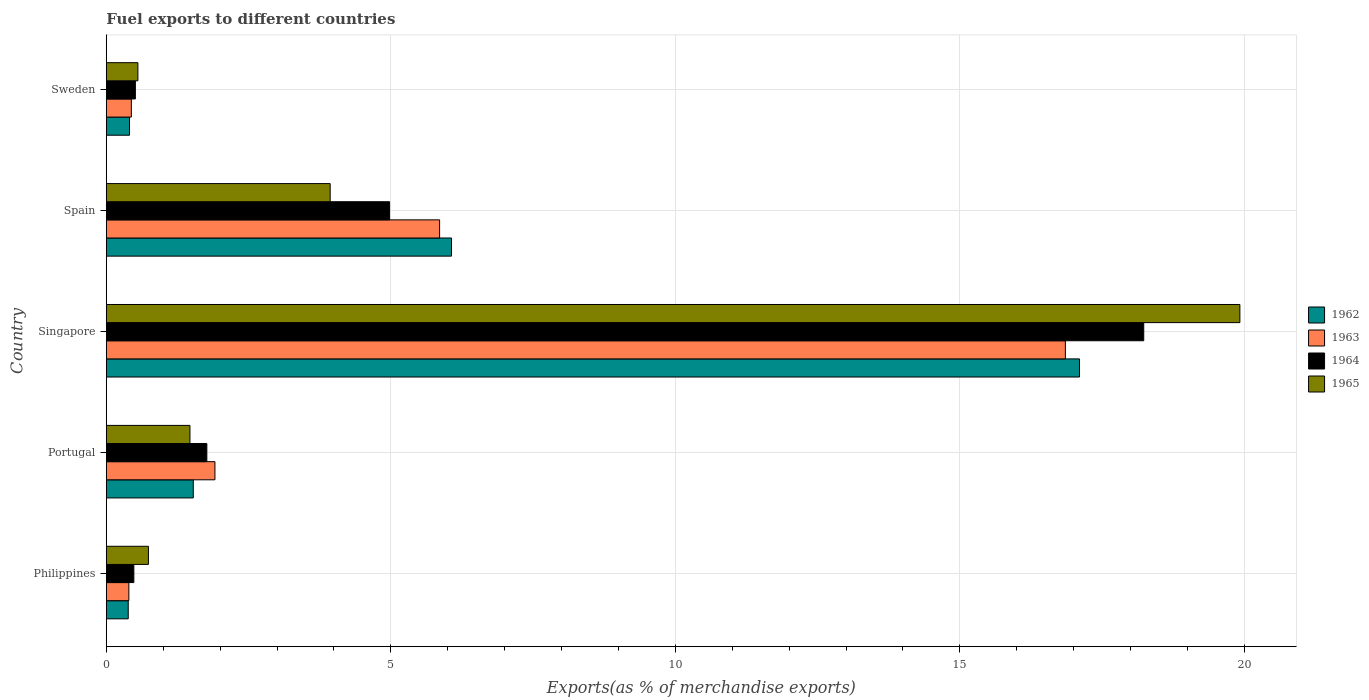Are the number of bars per tick equal to the number of legend labels?
Your answer should be compact. Yes. How many bars are there on the 3rd tick from the top?
Make the answer very short. 4. How many bars are there on the 5th tick from the bottom?
Offer a very short reply. 4. What is the label of the 5th group of bars from the top?
Your answer should be compact. Philippines. What is the percentage of exports to different countries in 1962 in Portugal?
Your answer should be very brief. 1.53. Across all countries, what is the maximum percentage of exports to different countries in 1965?
Provide a succinct answer. 19.92. Across all countries, what is the minimum percentage of exports to different countries in 1963?
Give a very brief answer. 0.4. In which country was the percentage of exports to different countries in 1965 maximum?
Make the answer very short. Singapore. What is the total percentage of exports to different countries in 1964 in the graph?
Offer a terse response. 25.97. What is the difference between the percentage of exports to different countries in 1964 in Spain and that in Sweden?
Provide a short and direct response. 4.47. What is the difference between the percentage of exports to different countries in 1964 in Portugal and the percentage of exports to different countries in 1965 in Philippines?
Offer a terse response. 1.03. What is the average percentage of exports to different countries in 1962 per country?
Provide a succinct answer. 5.1. What is the difference between the percentage of exports to different countries in 1964 and percentage of exports to different countries in 1965 in Sweden?
Your response must be concise. -0.04. What is the ratio of the percentage of exports to different countries in 1964 in Portugal to that in Spain?
Make the answer very short. 0.35. Is the percentage of exports to different countries in 1962 in Philippines less than that in Portugal?
Your answer should be compact. Yes. What is the difference between the highest and the second highest percentage of exports to different countries in 1963?
Offer a very short reply. 11. What is the difference between the highest and the lowest percentage of exports to different countries in 1964?
Your answer should be compact. 17.75. Is the sum of the percentage of exports to different countries in 1963 in Philippines and Spain greater than the maximum percentage of exports to different countries in 1962 across all countries?
Offer a very short reply. No. What does the 2nd bar from the top in Philippines represents?
Your answer should be compact. 1964. Is it the case that in every country, the sum of the percentage of exports to different countries in 1964 and percentage of exports to different countries in 1963 is greater than the percentage of exports to different countries in 1962?
Offer a terse response. Yes. How many bars are there?
Your answer should be compact. 20. Are all the bars in the graph horizontal?
Provide a short and direct response. Yes. How many countries are there in the graph?
Ensure brevity in your answer.  5. What is the difference between two consecutive major ticks on the X-axis?
Give a very brief answer. 5. Where does the legend appear in the graph?
Offer a very short reply. Center right. How many legend labels are there?
Offer a terse response. 4. How are the legend labels stacked?
Offer a very short reply. Vertical. What is the title of the graph?
Your answer should be compact. Fuel exports to different countries. What is the label or title of the X-axis?
Your answer should be compact. Exports(as % of merchandise exports). What is the Exports(as % of merchandise exports) in 1962 in Philippines?
Provide a succinct answer. 0.38. What is the Exports(as % of merchandise exports) of 1963 in Philippines?
Offer a very short reply. 0.4. What is the Exports(as % of merchandise exports) in 1964 in Philippines?
Give a very brief answer. 0.48. What is the Exports(as % of merchandise exports) of 1965 in Philippines?
Provide a short and direct response. 0.74. What is the Exports(as % of merchandise exports) in 1962 in Portugal?
Make the answer very short. 1.53. What is the Exports(as % of merchandise exports) of 1963 in Portugal?
Offer a very short reply. 1.91. What is the Exports(as % of merchandise exports) of 1964 in Portugal?
Your response must be concise. 1.77. What is the Exports(as % of merchandise exports) in 1965 in Portugal?
Provide a short and direct response. 1.47. What is the Exports(as % of merchandise exports) of 1962 in Singapore?
Keep it short and to the point. 17.1. What is the Exports(as % of merchandise exports) of 1963 in Singapore?
Your response must be concise. 16.85. What is the Exports(as % of merchandise exports) in 1964 in Singapore?
Make the answer very short. 18.23. What is the Exports(as % of merchandise exports) of 1965 in Singapore?
Provide a short and direct response. 19.92. What is the Exports(as % of merchandise exports) of 1962 in Spain?
Ensure brevity in your answer.  6.07. What is the Exports(as % of merchandise exports) of 1963 in Spain?
Make the answer very short. 5.86. What is the Exports(as % of merchandise exports) of 1964 in Spain?
Keep it short and to the point. 4.98. What is the Exports(as % of merchandise exports) in 1965 in Spain?
Ensure brevity in your answer.  3.93. What is the Exports(as % of merchandise exports) of 1962 in Sweden?
Provide a succinct answer. 0.41. What is the Exports(as % of merchandise exports) of 1963 in Sweden?
Provide a short and direct response. 0.44. What is the Exports(as % of merchandise exports) in 1964 in Sweden?
Ensure brevity in your answer.  0.51. What is the Exports(as % of merchandise exports) of 1965 in Sweden?
Offer a very short reply. 0.55. Across all countries, what is the maximum Exports(as % of merchandise exports) in 1962?
Offer a terse response. 17.1. Across all countries, what is the maximum Exports(as % of merchandise exports) in 1963?
Give a very brief answer. 16.85. Across all countries, what is the maximum Exports(as % of merchandise exports) of 1964?
Offer a very short reply. 18.23. Across all countries, what is the maximum Exports(as % of merchandise exports) in 1965?
Ensure brevity in your answer.  19.92. Across all countries, what is the minimum Exports(as % of merchandise exports) of 1962?
Provide a succinct answer. 0.38. Across all countries, what is the minimum Exports(as % of merchandise exports) of 1963?
Offer a very short reply. 0.4. Across all countries, what is the minimum Exports(as % of merchandise exports) in 1964?
Ensure brevity in your answer.  0.48. Across all countries, what is the minimum Exports(as % of merchandise exports) in 1965?
Keep it short and to the point. 0.55. What is the total Exports(as % of merchandise exports) of 1962 in the graph?
Provide a succinct answer. 25.49. What is the total Exports(as % of merchandise exports) of 1963 in the graph?
Offer a very short reply. 25.46. What is the total Exports(as % of merchandise exports) of 1964 in the graph?
Your response must be concise. 25.97. What is the total Exports(as % of merchandise exports) in 1965 in the graph?
Provide a short and direct response. 26.62. What is the difference between the Exports(as % of merchandise exports) in 1962 in Philippines and that in Portugal?
Your answer should be very brief. -1.14. What is the difference between the Exports(as % of merchandise exports) in 1963 in Philippines and that in Portugal?
Offer a very short reply. -1.51. What is the difference between the Exports(as % of merchandise exports) in 1964 in Philippines and that in Portugal?
Provide a short and direct response. -1.28. What is the difference between the Exports(as % of merchandise exports) in 1965 in Philippines and that in Portugal?
Offer a terse response. -0.73. What is the difference between the Exports(as % of merchandise exports) in 1962 in Philippines and that in Singapore?
Your response must be concise. -16.72. What is the difference between the Exports(as % of merchandise exports) of 1963 in Philippines and that in Singapore?
Offer a terse response. -16.46. What is the difference between the Exports(as % of merchandise exports) in 1964 in Philippines and that in Singapore?
Offer a very short reply. -17.75. What is the difference between the Exports(as % of merchandise exports) in 1965 in Philippines and that in Singapore?
Provide a succinct answer. -19.18. What is the difference between the Exports(as % of merchandise exports) of 1962 in Philippines and that in Spain?
Provide a short and direct response. -5.68. What is the difference between the Exports(as % of merchandise exports) in 1963 in Philippines and that in Spain?
Make the answer very short. -5.46. What is the difference between the Exports(as % of merchandise exports) of 1964 in Philippines and that in Spain?
Give a very brief answer. -4.49. What is the difference between the Exports(as % of merchandise exports) of 1965 in Philippines and that in Spain?
Provide a succinct answer. -3.19. What is the difference between the Exports(as % of merchandise exports) in 1962 in Philippines and that in Sweden?
Make the answer very short. -0.02. What is the difference between the Exports(as % of merchandise exports) in 1963 in Philippines and that in Sweden?
Keep it short and to the point. -0.04. What is the difference between the Exports(as % of merchandise exports) in 1964 in Philippines and that in Sweden?
Ensure brevity in your answer.  -0.03. What is the difference between the Exports(as % of merchandise exports) of 1965 in Philippines and that in Sweden?
Keep it short and to the point. 0.19. What is the difference between the Exports(as % of merchandise exports) of 1962 in Portugal and that in Singapore?
Your answer should be compact. -15.58. What is the difference between the Exports(as % of merchandise exports) of 1963 in Portugal and that in Singapore?
Provide a short and direct response. -14.95. What is the difference between the Exports(as % of merchandise exports) in 1964 in Portugal and that in Singapore?
Ensure brevity in your answer.  -16.47. What is the difference between the Exports(as % of merchandise exports) in 1965 in Portugal and that in Singapore?
Provide a succinct answer. -18.45. What is the difference between the Exports(as % of merchandise exports) of 1962 in Portugal and that in Spain?
Offer a very short reply. -4.54. What is the difference between the Exports(as % of merchandise exports) in 1963 in Portugal and that in Spain?
Your answer should be very brief. -3.95. What is the difference between the Exports(as % of merchandise exports) in 1964 in Portugal and that in Spain?
Offer a very short reply. -3.21. What is the difference between the Exports(as % of merchandise exports) of 1965 in Portugal and that in Spain?
Provide a short and direct response. -2.46. What is the difference between the Exports(as % of merchandise exports) in 1962 in Portugal and that in Sweden?
Provide a succinct answer. 1.12. What is the difference between the Exports(as % of merchandise exports) of 1963 in Portugal and that in Sweden?
Provide a succinct answer. 1.47. What is the difference between the Exports(as % of merchandise exports) in 1964 in Portugal and that in Sweden?
Your answer should be compact. 1.26. What is the difference between the Exports(as % of merchandise exports) of 1965 in Portugal and that in Sweden?
Make the answer very short. 0.91. What is the difference between the Exports(as % of merchandise exports) of 1962 in Singapore and that in Spain?
Your answer should be very brief. 11.04. What is the difference between the Exports(as % of merchandise exports) of 1963 in Singapore and that in Spain?
Provide a succinct answer. 11. What is the difference between the Exports(as % of merchandise exports) of 1964 in Singapore and that in Spain?
Offer a terse response. 13.25. What is the difference between the Exports(as % of merchandise exports) in 1965 in Singapore and that in Spain?
Offer a very short reply. 15.99. What is the difference between the Exports(as % of merchandise exports) in 1962 in Singapore and that in Sweden?
Offer a terse response. 16.7. What is the difference between the Exports(as % of merchandise exports) of 1963 in Singapore and that in Sweden?
Your response must be concise. 16.42. What is the difference between the Exports(as % of merchandise exports) in 1964 in Singapore and that in Sweden?
Make the answer very short. 17.72. What is the difference between the Exports(as % of merchandise exports) in 1965 in Singapore and that in Sweden?
Give a very brief answer. 19.37. What is the difference between the Exports(as % of merchandise exports) in 1962 in Spain and that in Sweden?
Offer a terse response. 5.66. What is the difference between the Exports(as % of merchandise exports) in 1963 in Spain and that in Sweden?
Keep it short and to the point. 5.42. What is the difference between the Exports(as % of merchandise exports) in 1964 in Spain and that in Sweden?
Provide a short and direct response. 4.47. What is the difference between the Exports(as % of merchandise exports) of 1965 in Spain and that in Sweden?
Your response must be concise. 3.38. What is the difference between the Exports(as % of merchandise exports) of 1962 in Philippines and the Exports(as % of merchandise exports) of 1963 in Portugal?
Offer a very short reply. -1.52. What is the difference between the Exports(as % of merchandise exports) in 1962 in Philippines and the Exports(as % of merchandise exports) in 1964 in Portugal?
Make the answer very short. -1.38. What is the difference between the Exports(as % of merchandise exports) in 1962 in Philippines and the Exports(as % of merchandise exports) in 1965 in Portugal?
Give a very brief answer. -1.08. What is the difference between the Exports(as % of merchandise exports) in 1963 in Philippines and the Exports(as % of merchandise exports) in 1964 in Portugal?
Your answer should be very brief. -1.37. What is the difference between the Exports(as % of merchandise exports) in 1963 in Philippines and the Exports(as % of merchandise exports) in 1965 in Portugal?
Your response must be concise. -1.07. What is the difference between the Exports(as % of merchandise exports) of 1964 in Philippines and the Exports(as % of merchandise exports) of 1965 in Portugal?
Make the answer very short. -0.99. What is the difference between the Exports(as % of merchandise exports) in 1962 in Philippines and the Exports(as % of merchandise exports) in 1963 in Singapore?
Ensure brevity in your answer.  -16.47. What is the difference between the Exports(as % of merchandise exports) in 1962 in Philippines and the Exports(as % of merchandise exports) in 1964 in Singapore?
Offer a very short reply. -17.85. What is the difference between the Exports(as % of merchandise exports) in 1962 in Philippines and the Exports(as % of merchandise exports) in 1965 in Singapore?
Give a very brief answer. -19.54. What is the difference between the Exports(as % of merchandise exports) of 1963 in Philippines and the Exports(as % of merchandise exports) of 1964 in Singapore?
Make the answer very short. -17.84. What is the difference between the Exports(as % of merchandise exports) of 1963 in Philippines and the Exports(as % of merchandise exports) of 1965 in Singapore?
Keep it short and to the point. -19.53. What is the difference between the Exports(as % of merchandise exports) in 1964 in Philippines and the Exports(as % of merchandise exports) in 1965 in Singapore?
Give a very brief answer. -19.44. What is the difference between the Exports(as % of merchandise exports) in 1962 in Philippines and the Exports(as % of merchandise exports) in 1963 in Spain?
Your answer should be compact. -5.47. What is the difference between the Exports(as % of merchandise exports) of 1962 in Philippines and the Exports(as % of merchandise exports) of 1964 in Spain?
Your answer should be compact. -4.59. What is the difference between the Exports(as % of merchandise exports) in 1962 in Philippines and the Exports(as % of merchandise exports) in 1965 in Spain?
Offer a very short reply. -3.55. What is the difference between the Exports(as % of merchandise exports) of 1963 in Philippines and the Exports(as % of merchandise exports) of 1964 in Spain?
Keep it short and to the point. -4.58. What is the difference between the Exports(as % of merchandise exports) in 1963 in Philippines and the Exports(as % of merchandise exports) in 1965 in Spain?
Your response must be concise. -3.54. What is the difference between the Exports(as % of merchandise exports) in 1964 in Philippines and the Exports(as % of merchandise exports) in 1965 in Spain?
Offer a terse response. -3.45. What is the difference between the Exports(as % of merchandise exports) in 1962 in Philippines and the Exports(as % of merchandise exports) in 1963 in Sweden?
Give a very brief answer. -0.05. What is the difference between the Exports(as % of merchandise exports) in 1962 in Philippines and the Exports(as % of merchandise exports) in 1964 in Sweden?
Offer a terse response. -0.13. What is the difference between the Exports(as % of merchandise exports) in 1962 in Philippines and the Exports(as % of merchandise exports) in 1965 in Sweden?
Your answer should be very brief. -0.17. What is the difference between the Exports(as % of merchandise exports) of 1963 in Philippines and the Exports(as % of merchandise exports) of 1964 in Sweden?
Ensure brevity in your answer.  -0.11. What is the difference between the Exports(as % of merchandise exports) in 1963 in Philippines and the Exports(as % of merchandise exports) in 1965 in Sweden?
Offer a very short reply. -0.16. What is the difference between the Exports(as % of merchandise exports) in 1964 in Philippines and the Exports(as % of merchandise exports) in 1965 in Sweden?
Offer a very short reply. -0.07. What is the difference between the Exports(as % of merchandise exports) of 1962 in Portugal and the Exports(as % of merchandise exports) of 1963 in Singapore?
Offer a very short reply. -15.33. What is the difference between the Exports(as % of merchandise exports) of 1962 in Portugal and the Exports(as % of merchandise exports) of 1964 in Singapore?
Keep it short and to the point. -16.7. What is the difference between the Exports(as % of merchandise exports) in 1962 in Portugal and the Exports(as % of merchandise exports) in 1965 in Singapore?
Offer a terse response. -18.39. What is the difference between the Exports(as % of merchandise exports) of 1963 in Portugal and the Exports(as % of merchandise exports) of 1964 in Singapore?
Ensure brevity in your answer.  -16.32. What is the difference between the Exports(as % of merchandise exports) in 1963 in Portugal and the Exports(as % of merchandise exports) in 1965 in Singapore?
Give a very brief answer. -18.01. What is the difference between the Exports(as % of merchandise exports) in 1964 in Portugal and the Exports(as % of merchandise exports) in 1965 in Singapore?
Your answer should be compact. -18.16. What is the difference between the Exports(as % of merchandise exports) in 1962 in Portugal and the Exports(as % of merchandise exports) in 1963 in Spain?
Keep it short and to the point. -4.33. What is the difference between the Exports(as % of merchandise exports) in 1962 in Portugal and the Exports(as % of merchandise exports) in 1964 in Spain?
Provide a short and direct response. -3.45. What is the difference between the Exports(as % of merchandise exports) in 1962 in Portugal and the Exports(as % of merchandise exports) in 1965 in Spain?
Ensure brevity in your answer.  -2.41. What is the difference between the Exports(as % of merchandise exports) in 1963 in Portugal and the Exports(as % of merchandise exports) in 1964 in Spain?
Ensure brevity in your answer.  -3.07. What is the difference between the Exports(as % of merchandise exports) in 1963 in Portugal and the Exports(as % of merchandise exports) in 1965 in Spain?
Provide a short and direct response. -2.03. What is the difference between the Exports(as % of merchandise exports) in 1964 in Portugal and the Exports(as % of merchandise exports) in 1965 in Spain?
Offer a terse response. -2.17. What is the difference between the Exports(as % of merchandise exports) in 1962 in Portugal and the Exports(as % of merchandise exports) in 1963 in Sweden?
Your answer should be very brief. 1.09. What is the difference between the Exports(as % of merchandise exports) of 1962 in Portugal and the Exports(as % of merchandise exports) of 1964 in Sweden?
Provide a short and direct response. 1.02. What is the difference between the Exports(as % of merchandise exports) in 1962 in Portugal and the Exports(as % of merchandise exports) in 1965 in Sweden?
Ensure brevity in your answer.  0.97. What is the difference between the Exports(as % of merchandise exports) of 1963 in Portugal and the Exports(as % of merchandise exports) of 1964 in Sweden?
Offer a terse response. 1.4. What is the difference between the Exports(as % of merchandise exports) in 1963 in Portugal and the Exports(as % of merchandise exports) in 1965 in Sweden?
Make the answer very short. 1.35. What is the difference between the Exports(as % of merchandise exports) in 1964 in Portugal and the Exports(as % of merchandise exports) in 1965 in Sweden?
Your answer should be very brief. 1.21. What is the difference between the Exports(as % of merchandise exports) of 1962 in Singapore and the Exports(as % of merchandise exports) of 1963 in Spain?
Offer a terse response. 11.25. What is the difference between the Exports(as % of merchandise exports) of 1962 in Singapore and the Exports(as % of merchandise exports) of 1964 in Spain?
Make the answer very short. 12.13. What is the difference between the Exports(as % of merchandise exports) in 1962 in Singapore and the Exports(as % of merchandise exports) in 1965 in Spain?
Provide a succinct answer. 13.17. What is the difference between the Exports(as % of merchandise exports) of 1963 in Singapore and the Exports(as % of merchandise exports) of 1964 in Spain?
Your answer should be very brief. 11.88. What is the difference between the Exports(as % of merchandise exports) of 1963 in Singapore and the Exports(as % of merchandise exports) of 1965 in Spain?
Give a very brief answer. 12.92. What is the difference between the Exports(as % of merchandise exports) in 1964 in Singapore and the Exports(as % of merchandise exports) in 1965 in Spain?
Offer a very short reply. 14.3. What is the difference between the Exports(as % of merchandise exports) of 1962 in Singapore and the Exports(as % of merchandise exports) of 1963 in Sweden?
Your answer should be compact. 16.66. What is the difference between the Exports(as % of merchandise exports) in 1962 in Singapore and the Exports(as % of merchandise exports) in 1964 in Sweden?
Ensure brevity in your answer.  16.59. What is the difference between the Exports(as % of merchandise exports) in 1962 in Singapore and the Exports(as % of merchandise exports) in 1965 in Sweden?
Keep it short and to the point. 16.55. What is the difference between the Exports(as % of merchandise exports) of 1963 in Singapore and the Exports(as % of merchandise exports) of 1964 in Sweden?
Ensure brevity in your answer.  16.34. What is the difference between the Exports(as % of merchandise exports) of 1963 in Singapore and the Exports(as % of merchandise exports) of 1965 in Sweden?
Your answer should be compact. 16.3. What is the difference between the Exports(as % of merchandise exports) of 1964 in Singapore and the Exports(as % of merchandise exports) of 1965 in Sweden?
Your answer should be compact. 17.68. What is the difference between the Exports(as % of merchandise exports) in 1962 in Spain and the Exports(as % of merchandise exports) in 1963 in Sweden?
Provide a short and direct response. 5.63. What is the difference between the Exports(as % of merchandise exports) of 1962 in Spain and the Exports(as % of merchandise exports) of 1964 in Sweden?
Make the answer very short. 5.56. What is the difference between the Exports(as % of merchandise exports) of 1962 in Spain and the Exports(as % of merchandise exports) of 1965 in Sweden?
Provide a succinct answer. 5.51. What is the difference between the Exports(as % of merchandise exports) in 1963 in Spain and the Exports(as % of merchandise exports) in 1964 in Sweden?
Give a very brief answer. 5.35. What is the difference between the Exports(as % of merchandise exports) in 1963 in Spain and the Exports(as % of merchandise exports) in 1965 in Sweden?
Provide a short and direct response. 5.3. What is the difference between the Exports(as % of merchandise exports) of 1964 in Spain and the Exports(as % of merchandise exports) of 1965 in Sweden?
Offer a terse response. 4.42. What is the average Exports(as % of merchandise exports) in 1962 per country?
Your response must be concise. 5.1. What is the average Exports(as % of merchandise exports) of 1963 per country?
Your answer should be compact. 5.09. What is the average Exports(as % of merchandise exports) in 1964 per country?
Provide a short and direct response. 5.19. What is the average Exports(as % of merchandise exports) of 1965 per country?
Ensure brevity in your answer.  5.32. What is the difference between the Exports(as % of merchandise exports) in 1962 and Exports(as % of merchandise exports) in 1963 in Philippines?
Your response must be concise. -0.01. What is the difference between the Exports(as % of merchandise exports) of 1962 and Exports(as % of merchandise exports) of 1964 in Philippines?
Your response must be concise. -0.1. What is the difference between the Exports(as % of merchandise exports) in 1962 and Exports(as % of merchandise exports) in 1965 in Philippines?
Make the answer very short. -0.35. What is the difference between the Exports(as % of merchandise exports) of 1963 and Exports(as % of merchandise exports) of 1964 in Philippines?
Your answer should be compact. -0.09. What is the difference between the Exports(as % of merchandise exports) of 1963 and Exports(as % of merchandise exports) of 1965 in Philippines?
Make the answer very short. -0.34. What is the difference between the Exports(as % of merchandise exports) in 1964 and Exports(as % of merchandise exports) in 1965 in Philippines?
Your answer should be compact. -0.26. What is the difference between the Exports(as % of merchandise exports) of 1962 and Exports(as % of merchandise exports) of 1963 in Portugal?
Provide a succinct answer. -0.38. What is the difference between the Exports(as % of merchandise exports) in 1962 and Exports(as % of merchandise exports) in 1964 in Portugal?
Provide a short and direct response. -0.24. What is the difference between the Exports(as % of merchandise exports) in 1962 and Exports(as % of merchandise exports) in 1965 in Portugal?
Provide a short and direct response. 0.06. What is the difference between the Exports(as % of merchandise exports) in 1963 and Exports(as % of merchandise exports) in 1964 in Portugal?
Provide a succinct answer. 0.14. What is the difference between the Exports(as % of merchandise exports) in 1963 and Exports(as % of merchandise exports) in 1965 in Portugal?
Keep it short and to the point. 0.44. What is the difference between the Exports(as % of merchandise exports) of 1964 and Exports(as % of merchandise exports) of 1965 in Portugal?
Provide a succinct answer. 0.3. What is the difference between the Exports(as % of merchandise exports) of 1962 and Exports(as % of merchandise exports) of 1963 in Singapore?
Provide a short and direct response. 0.25. What is the difference between the Exports(as % of merchandise exports) in 1962 and Exports(as % of merchandise exports) in 1964 in Singapore?
Give a very brief answer. -1.13. What is the difference between the Exports(as % of merchandise exports) in 1962 and Exports(as % of merchandise exports) in 1965 in Singapore?
Offer a terse response. -2.82. What is the difference between the Exports(as % of merchandise exports) in 1963 and Exports(as % of merchandise exports) in 1964 in Singapore?
Provide a succinct answer. -1.38. What is the difference between the Exports(as % of merchandise exports) of 1963 and Exports(as % of merchandise exports) of 1965 in Singapore?
Offer a terse response. -3.07. What is the difference between the Exports(as % of merchandise exports) in 1964 and Exports(as % of merchandise exports) in 1965 in Singapore?
Your answer should be compact. -1.69. What is the difference between the Exports(as % of merchandise exports) of 1962 and Exports(as % of merchandise exports) of 1963 in Spain?
Keep it short and to the point. 0.21. What is the difference between the Exports(as % of merchandise exports) of 1962 and Exports(as % of merchandise exports) of 1964 in Spain?
Make the answer very short. 1.09. What is the difference between the Exports(as % of merchandise exports) of 1962 and Exports(as % of merchandise exports) of 1965 in Spain?
Provide a succinct answer. 2.13. What is the difference between the Exports(as % of merchandise exports) in 1963 and Exports(as % of merchandise exports) in 1964 in Spain?
Your answer should be compact. 0.88. What is the difference between the Exports(as % of merchandise exports) in 1963 and Exports(as % of merchandise exports) in 1965 in Spain?
Provide a succinct answer. 1.92. What is the difference between the Exports(as % of merchandise exports) of 1964 and Exports(as % of merchandise exports) of 1965 in Spain?
Your answer should be compact. 1.04. What is the difference between the Exports(as % of merchandise exports) in 1962 and Exports(as % of merchandise exports) in 1963 in Sweden?
Your answer should be compact. -0.03. What is the difference between the Exports(as % of merchandise exports) in 1962 and Exports(as % of merchandise exports) in 1964 in Sweden?
Your answer should be very brief. -0.1. What is the difference between the Exports(as % of merchandise exports) in 1962 and Exports(as % of merchandise exports) in 1965 in Sweden?
Make the answer very short. -0.15. What is the difference between the Exports(as % of merchandise exports) of 1963 and Exports(as % of merchandise exports) of 1964 in Sweden?
Your answer should be compact. -0.07. What is the difference between the Exports(as % of merchandise exports) in 1963 and Exports(as % of merchandise exports) in 1965 in Sweden?
Your response must be concise. -0.12. What is the difference between the Exports(as % of merchandise exports) in 1964 and Exports(as % of merchandise exports) in 1965 in Sweden?
Your response must be concise. -0.04. What is the ratio of the Exports(as % of merchandise exports) in 1962 in Philippines to that in Portugal?
Offer a very short reply. 0.25. What is the ratio of the Exports(as % of merchandise exports) in 1963 in Philippines to that in Portugal?
Provide a short and direct response. 0.21. What is the ratio of the Exports(as % of merchandise exports) of 1964 in Philippines to that in Portugal?
Give a very brief answer. 0.27. What is the ratio of the Exports(as % of merchandise exports) of 1965 in Philippines to that in Portugal?
Ensure brevity in your answer.  0.5. What is the ratio of the Exports(as % of merchandise exports) of 1962 in Philippines to that in Singapore?
Provide a succinct answer. 0.02. What is the ratio of the Exports(as % of merchandise exports) of 1963 in Philippines to that in Singapore?
Your answer should be very brief. 0.02. What is the ratio of the Exports(as % of merchandise exports) in 1964 in Philippines to that in Singapore?
Keep it short and to the point. 0.03. What is the ratio of the Exports(as % of merchandise exports) in 1965 in Philippines to that in Singapore?
Provide a succinct answer. 0.04. What is the ratio of the Exports(as % of merchandise exports) in 1962 in Philippines to that in Spain?
Your answer should be compact. 0.06. What is the ratio of the Exports(as % of merchandise exports) in 1963 in Philippines to that in Spain?
Make the answer very short. 0.07. What is the ratio of the Exports(as % of merchandise exports) of 1964 in Philippines to that in Spain?
Keep it short and to the point. 0.1. What is the ratio of the Exports(as % of merchandise exports) of 1965 in Philippines to that in Spain?
Your answer should be very brief. 0.19. What is the ratio of the Exports(as % of merchandise exports) in 1962 in Philippines to that in Sweden?
Keep it short and to the point. 0.94. What is the ratio of the Exports(as % of merchandise exports) of 1963 in Philippines to that in Sweden?
Ensure brevity in your answer.  0.9. What is the ratio of the Exports(as % of merchandise exports) of 1964 in Philippines to that in Sweden?
Provide a succinct answer. 0.95. What is the ratio of the Exports(as % of merchandise exports) in 1965 in Philippines to that in Sweden?
Offer a very short reply. 1.33. What is the ratio of the Exports(as % of merchandise exports) of 1962 in Portugal to that in Singapore?
Your answer should be very brief. 0.09. What is the ratio of the Exports(as % of merchandise exports) of 1963 in Portugal to that in Singapore?
Give a very brief answer. 0.11. What is the ratio of the Exports(as % of merchandise exports) of 1964 in Portugal to that in Singapore?
Your answer should be compact. 0.1. What is the ratio of the Exports(as % of merchandise exports) of 1965 in Portugal to that in Singapore?
Keep it short and to the point. 0.07. What is the ratio of the Exports(as % of merchandise exports) in 1962 in Portugal to that in Spain?
Give a very brief answer. 0.25. What is the ratio of the Exports(as % of merchandise exports) in 1963 in Portugal to that in Spain?
Ensure brevity in your answer.  0.33. What is the ratio of the Exports(as % of merchandise exports) of 1964 in Portugal to that in Spain?
Ensure brevity in your answer.  0.35. What is the ratio of the Exports(as % of merchandise exports) of 1965 in Portugal to that in Spain?
Your answer should be compact. 0.37. What is the ratio of the Exports(as % of merchandise exports) of 1962 in Portugal to that in Sweden?
Your response must be concise. 3.75. What is the ratio of the Exports(as % of merchandise exports) in 1963 in Portugal to that in Sweden?
Your answer should be compact. 4.34. What is the ratio of the Exports(as % of merchandise exports) in 1964 in Portugal to that in Sweden?
Your response must be concise. 3.46. What is the ratio of the Exports(as % of merchandise exports) in 1965 in Portugal to that in Sweden?
Ensure brevity in your answer.  2.65. What is the ratio of the Exports(as % of merchandise exports) in 1962 in Singapore to that in Spain?
Offer a very short reply. 2.82. What is the ratio of the Exports(as % of merchandise exports) in 1963 in Singapore to that in Spain?
Make the answer very short. 2.88. What is the ratio of the Exports(as % of merchandise exports) in 1964 in Singapore to that in Spain?
Provide a succinct answer. 3.66. What is the ratio of the Exports(as % of merchandise exports) of 1965 in Singapore to that in Spain?
Give a very brief answer. 5.06. What is the ratio of the Exports(as % of merchandise exports) in 1962 in Singapore to that in Sweden?
Your answer should be very brief. 41.99. What is the ratio of the Exports(as % of merchandise exports) in 1963 in Singapore to that in Sweden?
Keep it short and to the point. 38.35. What is the ratio of the Exports(as % of merchandise exports) in 1964 in Singapore to that in Sweden?
Make the answer very short. 35.72. What is the ratio of the Exports(as % of merchandise exports) of 1965 in Singapore to that in Sweden?
Make the answer very short. 35.92. What is the ratio of the Exports(as % of merchandise exports) in 1962 in Spain to that in Sweden?
Give a very brief answer. 14.89. What is the ratio of the Exports(as % of merchandise exports) of 1963 in Spain to that in Sweden?
Provide a short and direct response. 13.33. What is the ratio of the Exports(as % of merchandise exports) of 1964 in Spain to that in Sweden?
Offer a terse response. 9.75. What is the ratio of the Exports(as % of merchandise exports) in 1965 in Spain to that in Sweden?
Offer a terse response. 7.09. What is the difference between the highest and the second highest Exports(as % of merchandise exports) of 1962?
Provide a short and direct response. 11.04. What is the difference between the highest and the second highest Exports(as % of merchandise exports) in 1963?
Your answer should be compact. 11. What is the difference between the highest and the second highest Exports(as % of merchandise exports) in 1964?
Give a very brief answer. 13.25. What is the difference between the highest and the second highest Exports(as % of merchandise exports) in 1965?
Make the answer very short. 15.99. What is the difference between the highest and the lowest Exports(as % of merchandise exports) in 1962?
Provide a succinct answer. 16.72. What is the difference between the highest and the lowest Exports(as % of merchandise exports) of 1963?
Give a very brief answer. 16.46. What is the difference between the highest and the lowest Exports(as % of merchandise exports) in 1964?
Provide a succinct answer. 17.75. What is the difference between the highest and the lowest Exports(as % of merchandise exports) in 1965?
Your answer should be very brief. 19.37. 